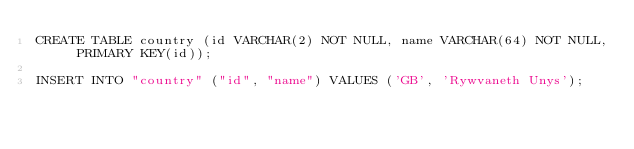<code> <loc_0><loc_0><loc_500><loc_500><_SQL_>CREATE TABLE country (id VARCHAR(2) NOT NULL, name VARCHAR(64) NOT NULL, PRIMARY KEY(id));

INSERT INTO "country" ("id", "name") VALUES ('GB', 'Rywvaneth Unys');
</code> 